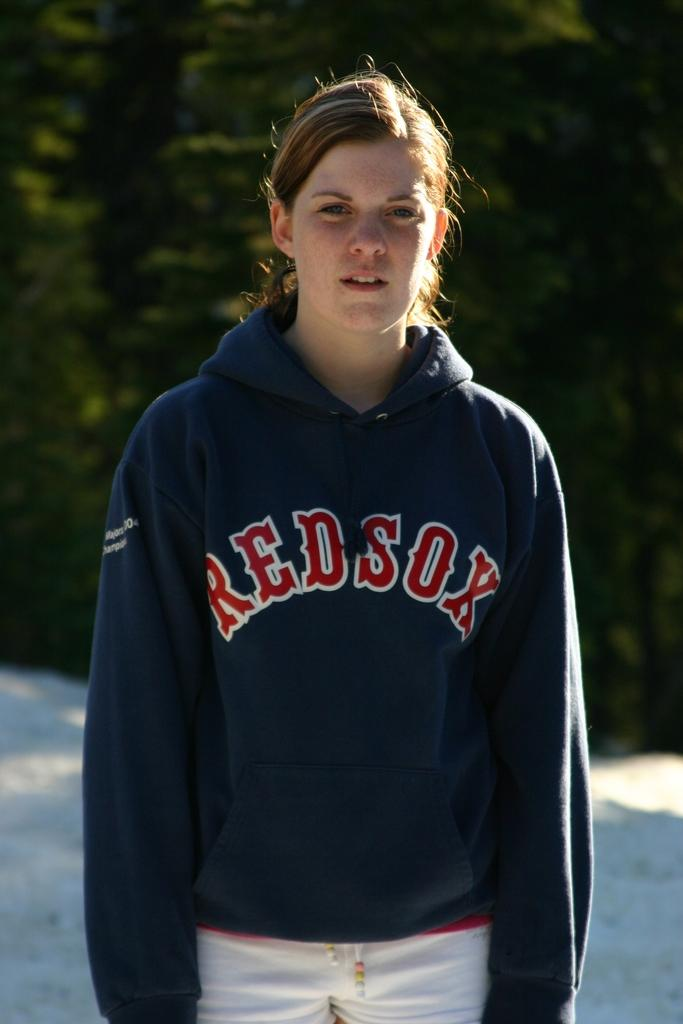Provide a one-sentence caption for the provided image. A girl is standing and looking at the camera with a REDSOX hoodie on her. 